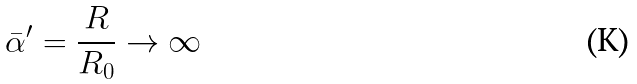<formula> <loc_0><loc_0><loc_500><loc_500>\bar { \alpha } ^ { \prime } = \frac { R } { R _ { 0 } } \rightarrow \infty</formula> 